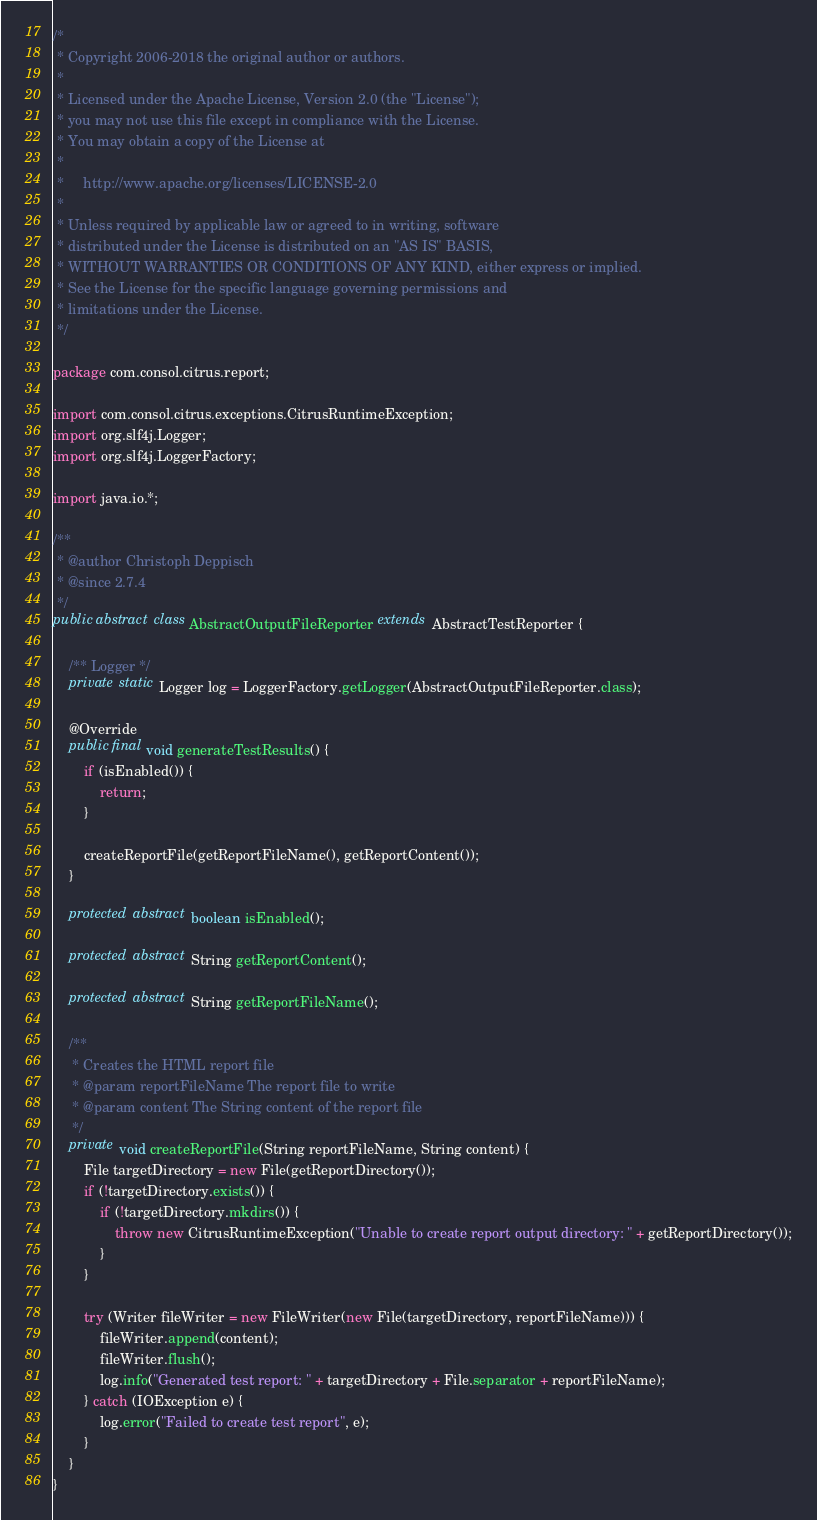Convert code to text. <code><loc_0><loc_0><loc_500><loc_500><_Java_>/*
 * Copyright 2006-2018 the original author or authors.
 *
 * Licensed under the Apache License, Version 2.0 (the "License");
 * you may not use this file except in compliance with the License.
 * You may obtain a copy of the License at
 *
 *     http://www.apache.org/licenses/LICENSE-2.0
 *
 * Unless required by applicable law or agreed to in writing, software
 * distributed under the License is distributed on an "AS IS" BASIS,
 * WITHOUT WARRANTIES OR CONDITIONS OF ANY KIND, either express or implied.
 * See the License for the specific language governing permissions and
 * limitations under the License.
 */

package com.consol.citrus.report;

import com.consol.citrus.exceptions.CitrusRuntimeException;
import org.slf4j.Logger;
import org.slf4j.LoggerFactory;

import java.io.*;

/**
 * @author Christoph Deppisch
 * @since 2.7.4
 */
public abstract class AbstractOutputFileReporter extends AbstractTestReporter {

    /** Logger */
    private static Logger log = LoggerFactory.getLogger(AbstractOutputFileReporter.class);

    @Override
    public final void generateTestResults() {
        if (isEnabled()) {
            return;
        }

        createReportFile(getReportFileName(), getReportContent());
    }

    protected abstract boolean isEnabled();

    protected abstract String getReportContent();

    protected abstract String getReportFileName();

    /**
     * Creates the HTML report file
     * @param reportFileName The report file to write
     * @param content The String content of the report file
     */
    private void createReportFile(String reportFileName, String content) {
        File targetDirectory = new File(getReportDirectory());
        if (!targetDirectory.exists()) {
            if (!targetDirectory.mkdirs()) {
                throw new CitrusRuntimeException("Unable to create report output directory: " + getReportDirectory());
            }
        }

        try (Writer fileWriter = new FileWriter(new File(targetDirectory, reportFileName))) {
            fileWriter.append(content);
            fileWriter.flush();
            log.info("Generated test report: " + targetDirectory + File.separator + reportFileName);
        } catch (IOException e) {
            log.error("Failed to create test report", e);
        }
    }
}
</code> 